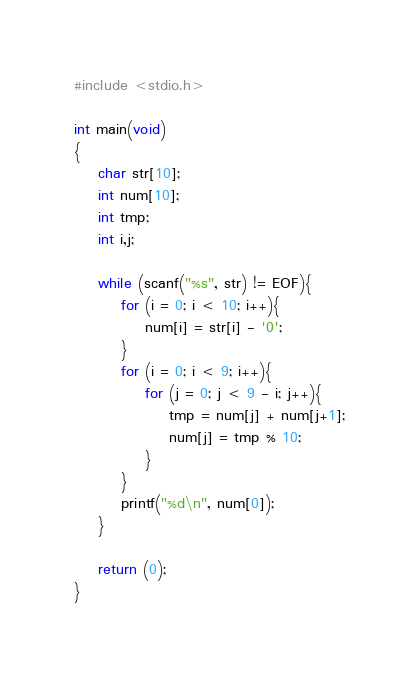<code> <loc_0><loc_0><loc_500><loc_500><_C_>#include <stdio.h>

int main(void)
{
    char str[10];
    int num[10];
    int tmp;
    int i,j;

    while (scanf("%s", str) != EOF){
        for (i = 0; i < 10; i++){
            num[i] = str[i] - '0';
        }
        for (i = 0; i < 9; i++){
            for (j = 0; j < 9 - i; j++){
                tmp = num[j] + num[j+1];
                num[j] = tmp % 10;
            }
        }
        printf("%d\n", num[0]);
    }

    return (0);
}
</code> 